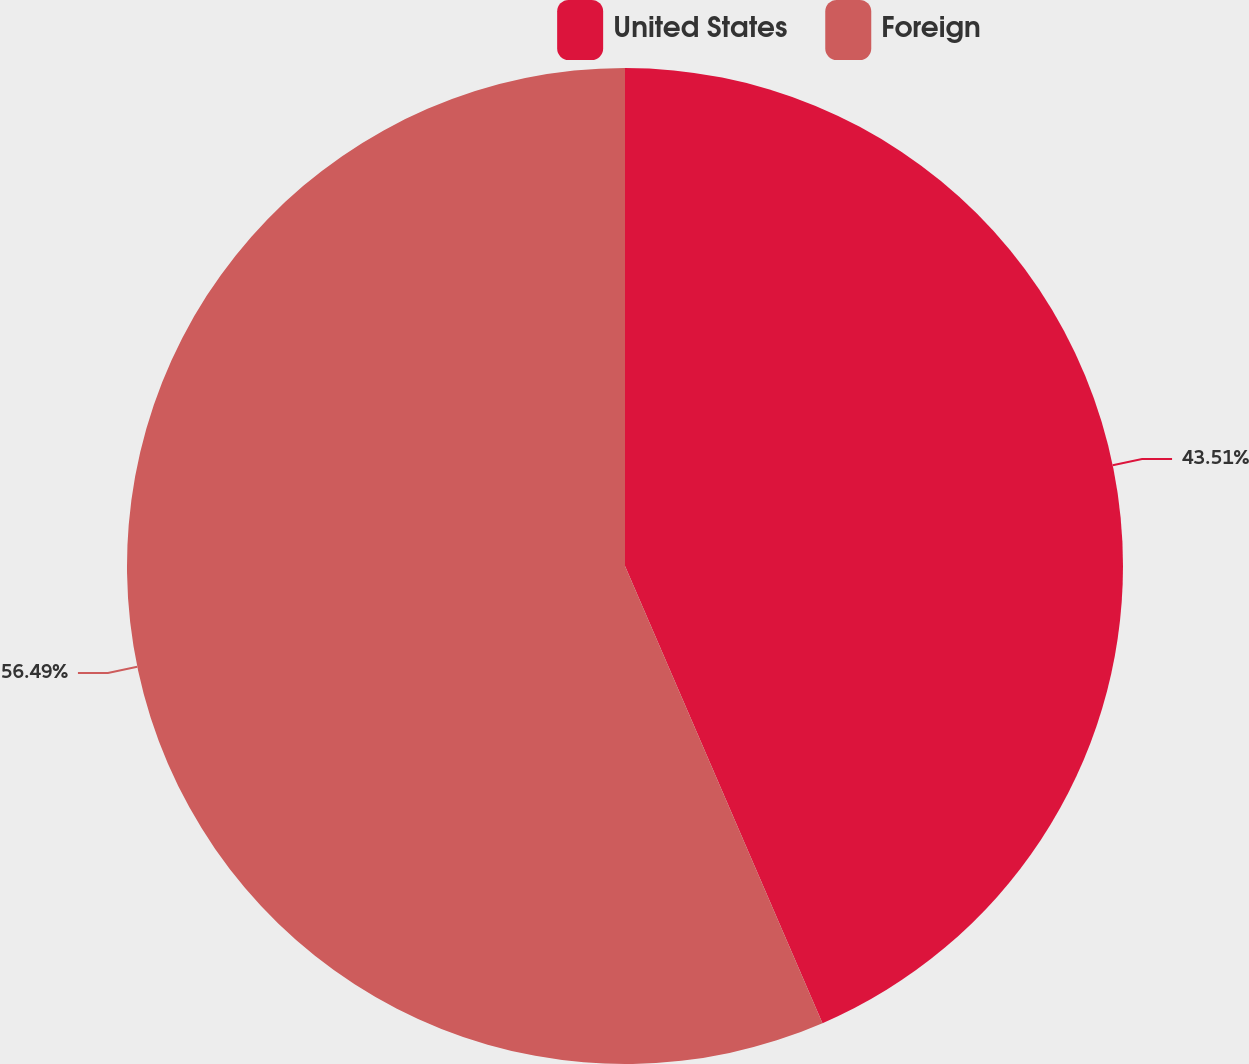Convert chart. <chart><loc_0><loc_0><loc_500><loc_500><pie_chart><fcel>United States<fcel>Foreign<nl><fcel>43.51%<fcel>56.49%<nl></chart> 